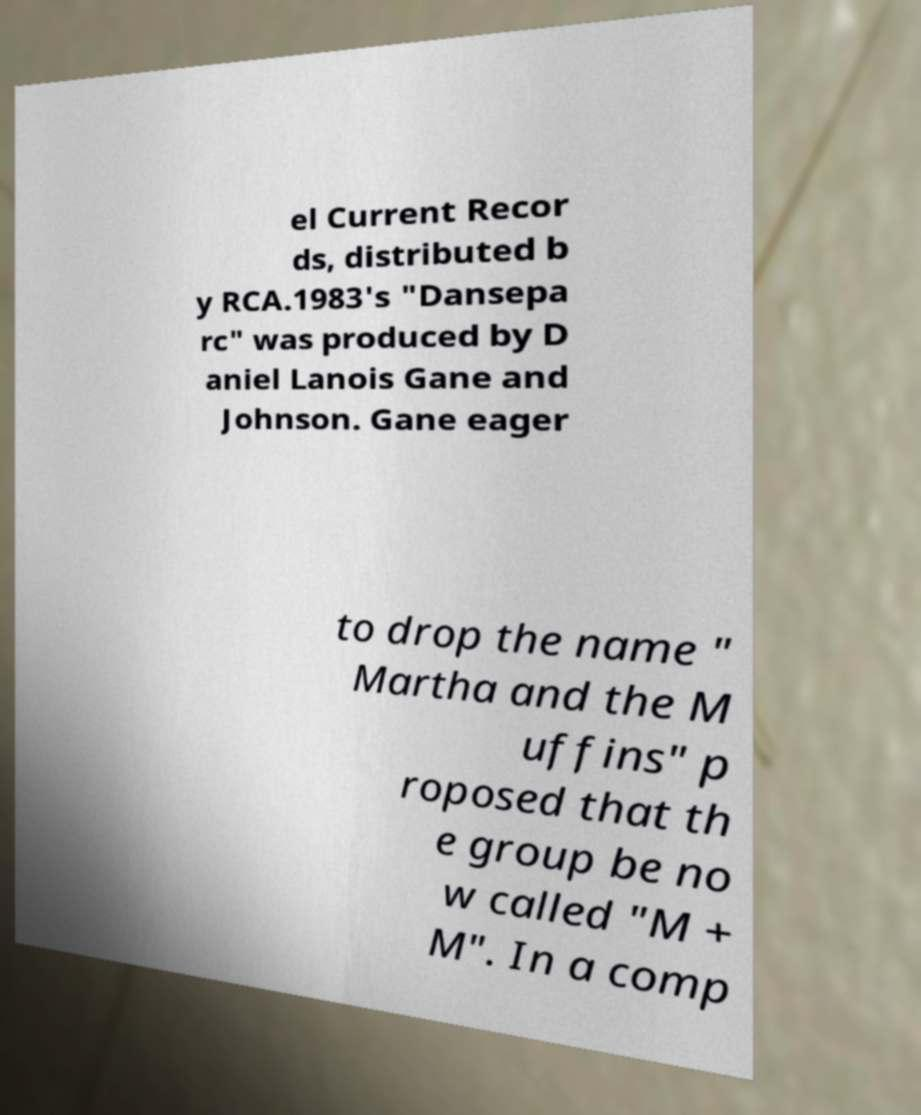For documentation purposes, I need the text within this image transcribed. Could you provide that? el Current Recor ds, distributed b y RCA.1983's "Dansepa rc" was produced by D aniel Lanois Gane and Johnson. Gane eager to drop the name " Martha and the M uffins" p roposed that th e group be no w called "M + M". In a comp 